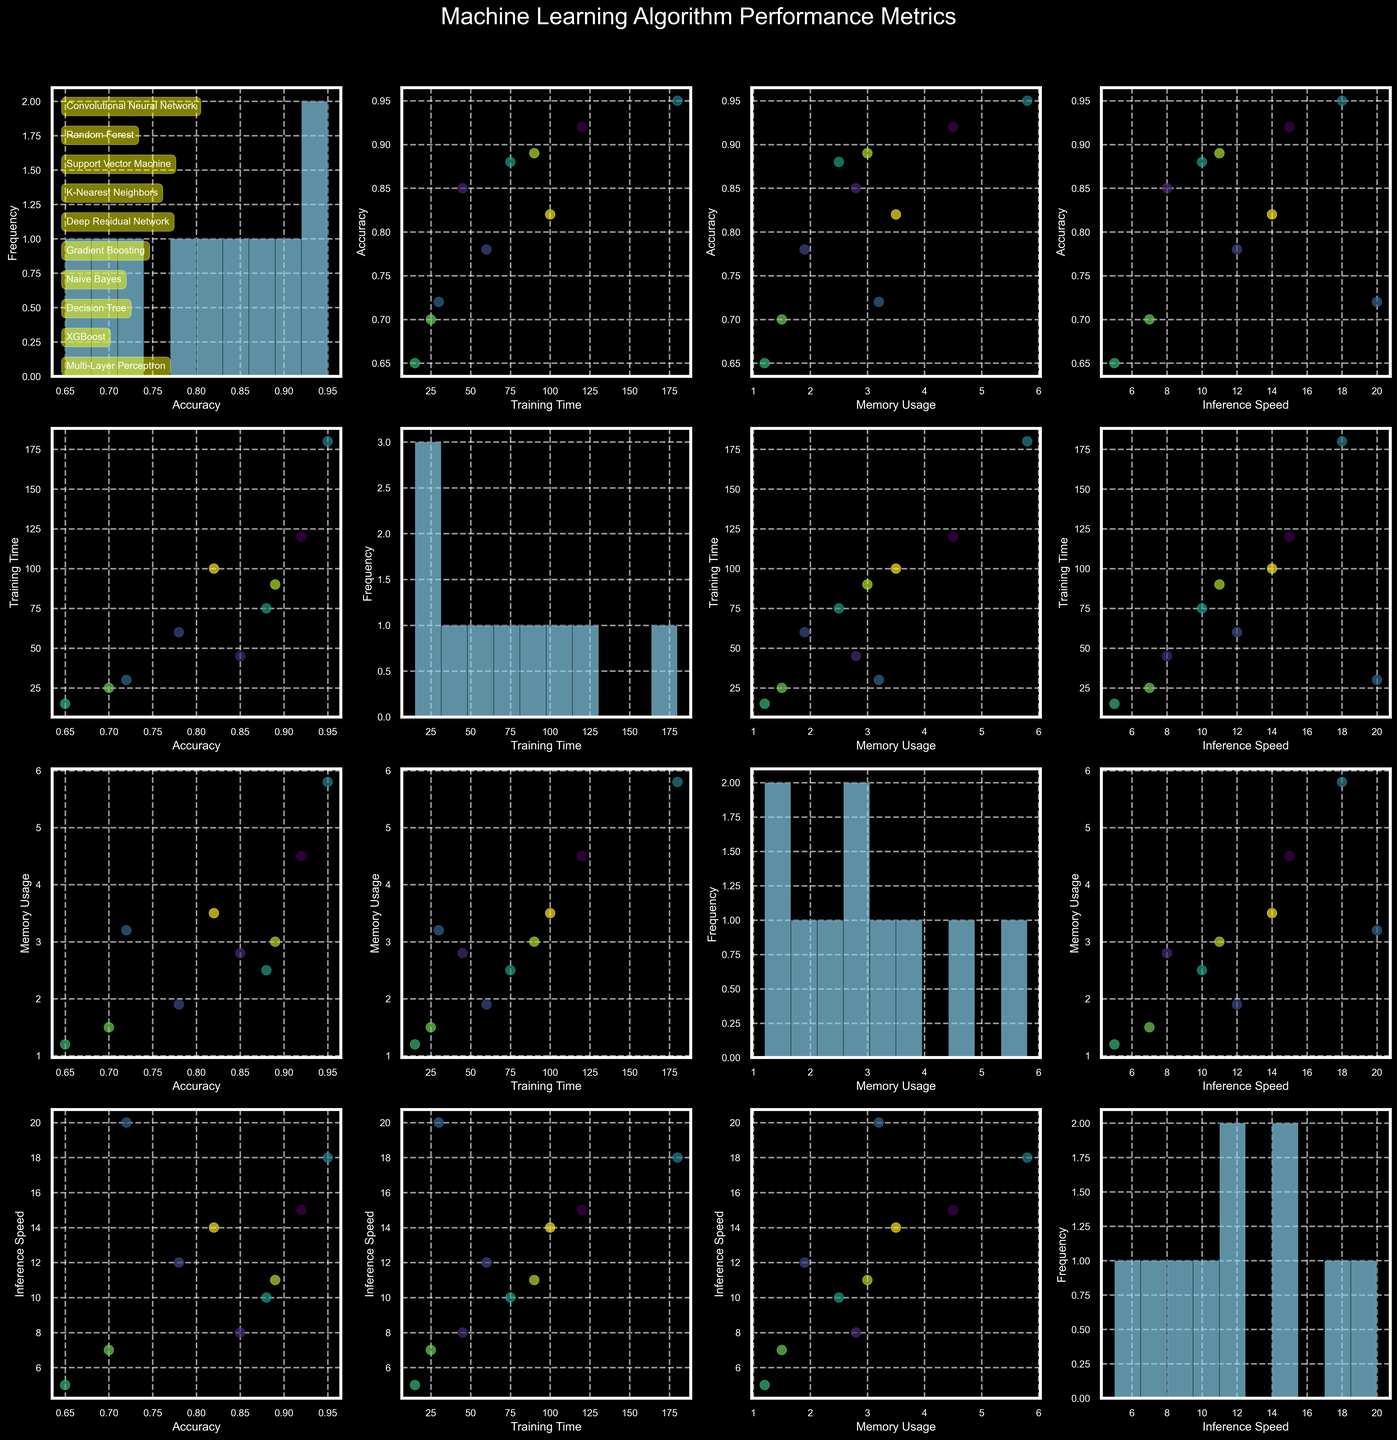Which algorithm has the highest accuracy? By examining the diagonal histogram plot labeled "Accuracy," we see that the algorithm with the tallest bar at the highest bin corresponds to the Deep Residual Network at 0.95 accuracy.
Answer: Deep Residual Network What's the difference in training time between the fastest and slowest algorithm? By looking at the diagonal histogram plot labeled "Training Time," the fastest training time is for Naive Bayes (15), and the slowest is for the Deep Residual Network (180). The difference is 180 - 15 = 165 minutes.
Answer: 165 minutes Which two algorithms have the least memory usage? By examining the "Memory Usage" histogram plot, we see that the two lowest bars correspond to the Naive Bayes and Decision Tree algorithms.
Answer: Naive Bayes and Decision Tree Which algorithm has higher inference speed, Random Forest or Support Vector Machine? By comparing the scatter points in the "Inference Speed vs. Accuracy" plot, the Support Vector Machine has a Y-value (inference speed) of 12, while Random Forest has a Y-value of 8. So, the Support Vector Machine has a higher inference speed.
Answer: Support Vector Machine How does the accuracy of the Multi-Layer Perceptron compare to the Naive Bayes? Referring to the scatter points annotated with algorithm names in the "Accuracy vs. Training Time" plot, Multi-Layer Perceptron has an accuracy of 0.82, which is higher than Naive Bayes with 0.65.
Answer: Higher Which algorithms lie in the top two accuracy bins? By examining the highest bars in the "Accuracy" histogram, the algorithms within the highest two bins are Deep Residual Network, Convolutional Neural Network, and XGBoost.
Answer: Deep Residual Network, Convolutional Neural Network, and XGBoost Between Random Forest and Gradient Boosting, which one requires more training time and by how much? By comparing the scatter points in the "Training Time vs. Accuracy" plot, Random Forest requires 45 minutes, while Gradient Boosting requires 75 minutes. The difference is 75 - 45 = 30 minutes.
Answer: Gradient Boosting by 30 minutes 